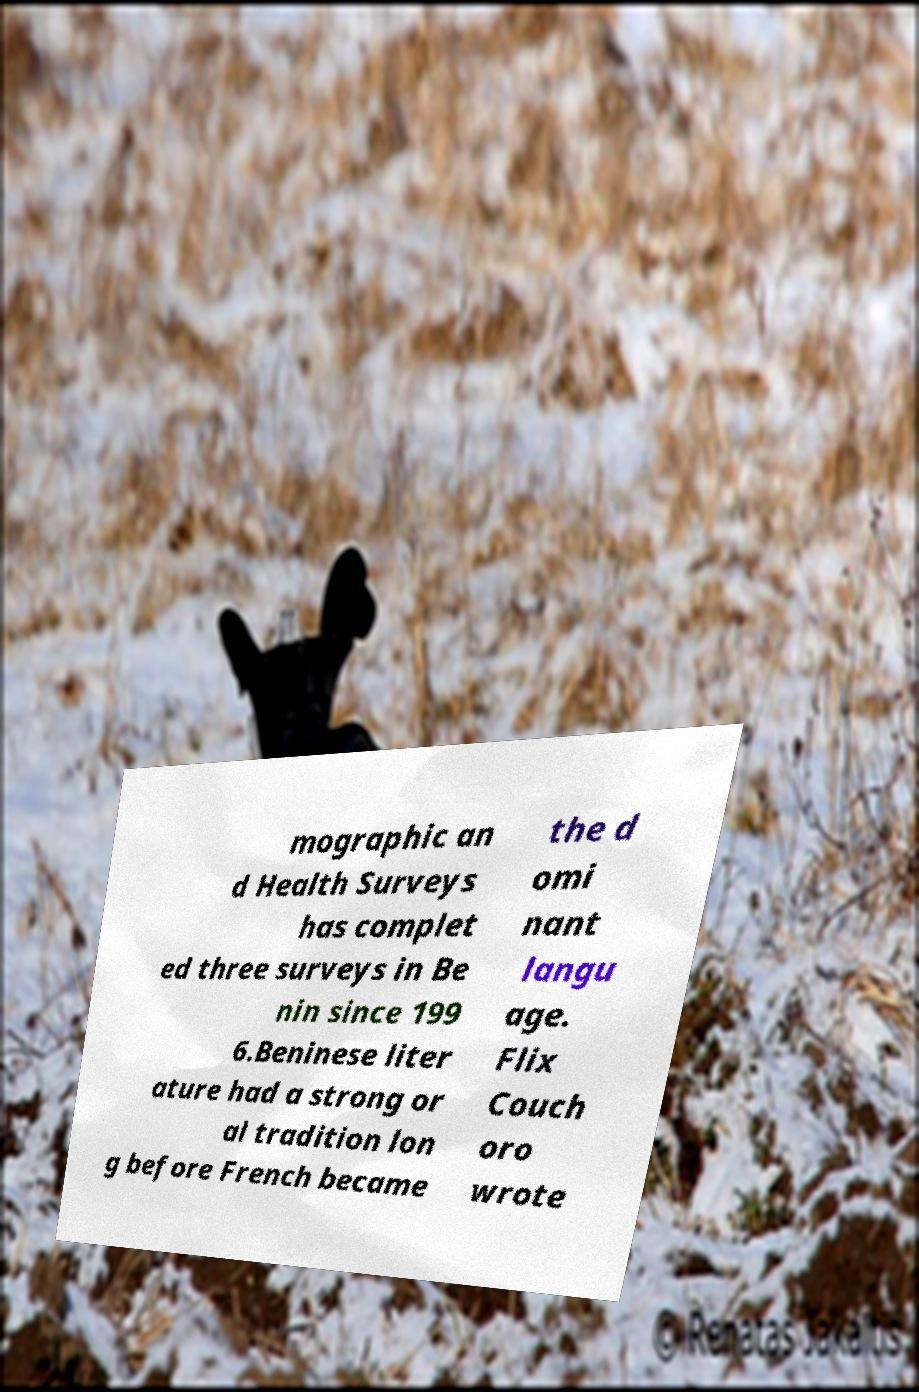What messages or text are displayed in this image? I need them in a readable, typed format. mographic an d Health Surveys has complet ed three surveys in Be nin since 199 6.Beninese liter ature had a strong or al tradition lon g before French became the d omi nant langu age. Flix Couch oro wrote 